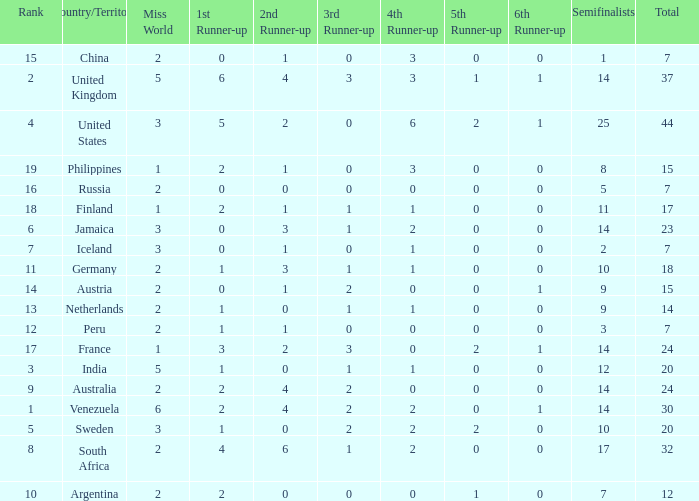What is the United States rank? 1.0. 